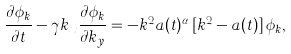Convert formula to latex. <formula><loc_0><loc_0><loc_500><loc_500>\frac { \partial \phi _ { k } } { \partial t } - \gamma k _ { x } \frac { \partial \phi _ { k } } { \partial k _ { y } } = - { k ^ { 2 } } a ( t ) ^ { \alpha } \, [ { k ^ { 2 } } - a ( t ) ] \, \phi _ { k } ,</formula> 